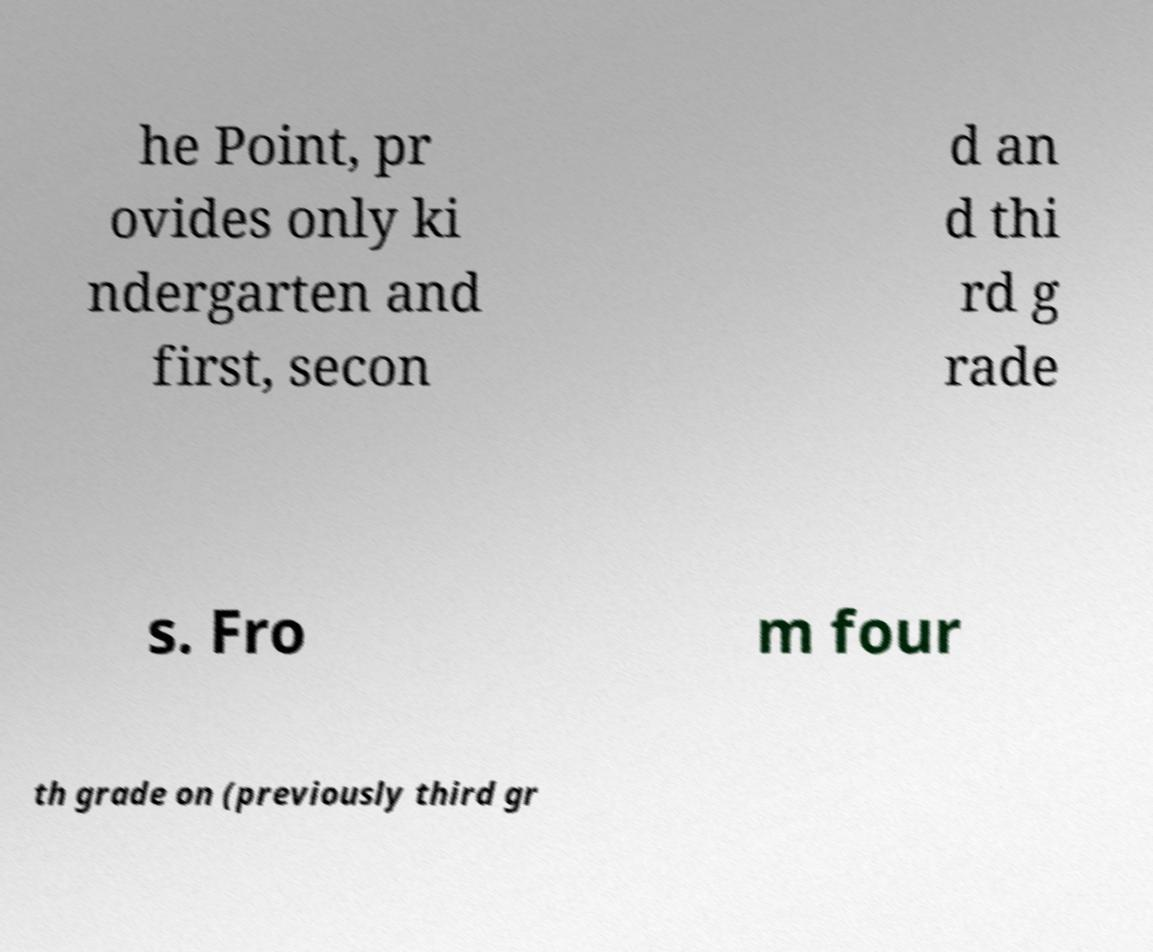Please read and relay the text visible in this image. What does it say? he Point, pr ovides only ki ndergarten and first, secon d an d thi rd g rade s. Fro m four th grade on (previously third gr 